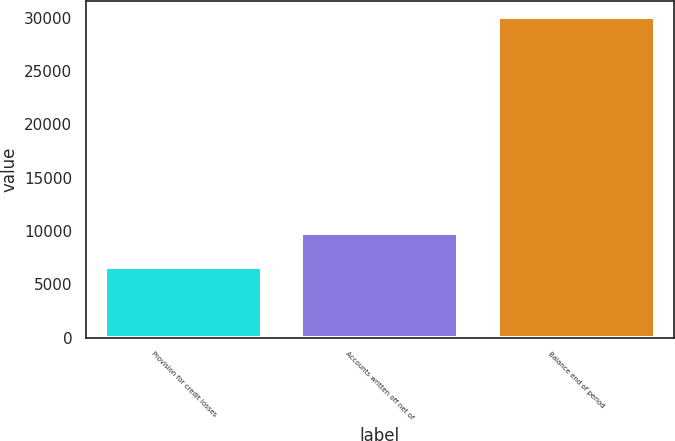Convert chart to OTSL. <chart><loc_0><loc_0><loc_500><loc_500><bar_chart><fcel>Provision for credit losses<fcel>Accounts written off net of<fcel>Balance end of period<nl><fcel>6635<fcel>9823<fcel>30094<nl></chart> 